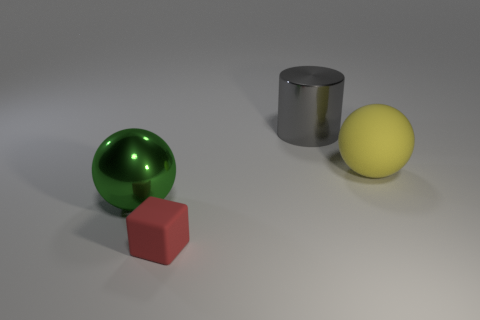Add 3 large matte balls. How many objects exist? 7 Subtract all cylinders. How many objects are left? 3 Add 4 tiny red matte blocks. How many tiny red matte blocks exist? 5 Subtract 1 yellow spheres. How many objects are left? 3 Subtract all small blue metal cylinders. Subtract all yellow matte things. How many objects are left? 3 Add 4 red rubber cubes. How many red rubber cubes are left? 5 